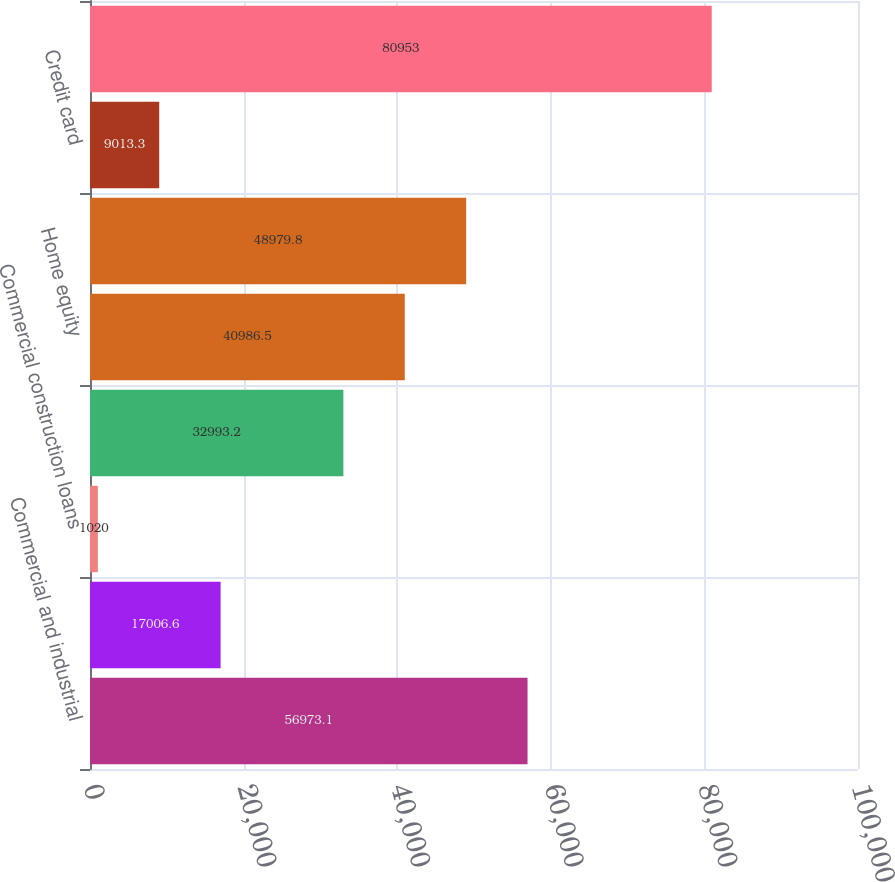<chart> <loc_0><loc_0><loc_500><loc_500><bar_chart><fcel>Commercial and industrial<fcel>Commercial mortgage<fcel>Commercial construction loans<fcel>Residential mortgage loans<fcel>Home equity<fcel>Automobile loans<fcel>Credit card<fcel>Total portfolio loans and<nl><fcel>56973.1<fcel>17006.6<fcel>1020<fcel>32993.2<fcel>40986.5<fcel>48979.8<fcel>9013.3<fcel>80953<nl></chart> 